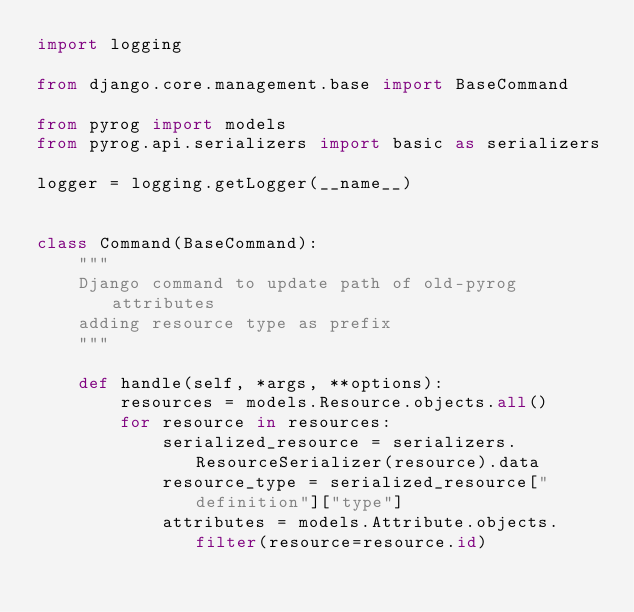<code> <loc_0><loc_0><loc_500><loc_500><_Python_>import logging

from django.core.management.base import BaseCommand

from pyrog import models
from pyrog.api.serializers import basic as serializers

logger = logging.getLogger(__name__)


class Command(BaseCommand):
    """
    Django command to update path of old-pyrog attributes
    adding resource type as prefix
    """

    def handle(self, *args, **options):
        resources = models.Resource.objects.all()
        for resource in resources:
            serialized_resource = serializers.ResourceSerializer(resource).data
            resource_type = serialized_resource["definition"]["type"]
            attributes = models.Attribute.objects.filter(resource=resource.id)</code> 